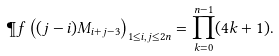Convert formula to latex. <formula><loc_0><loc_0><loc_500><loc_500>\P f \left ( ( j - i ) M _ { i + j - 3 } \right ) _ { 1 \leq i , j \leq 2 n } = \prod _ { k = 0 } ^ { n - 1 } ( 4 k + 1 ) .</formula> 